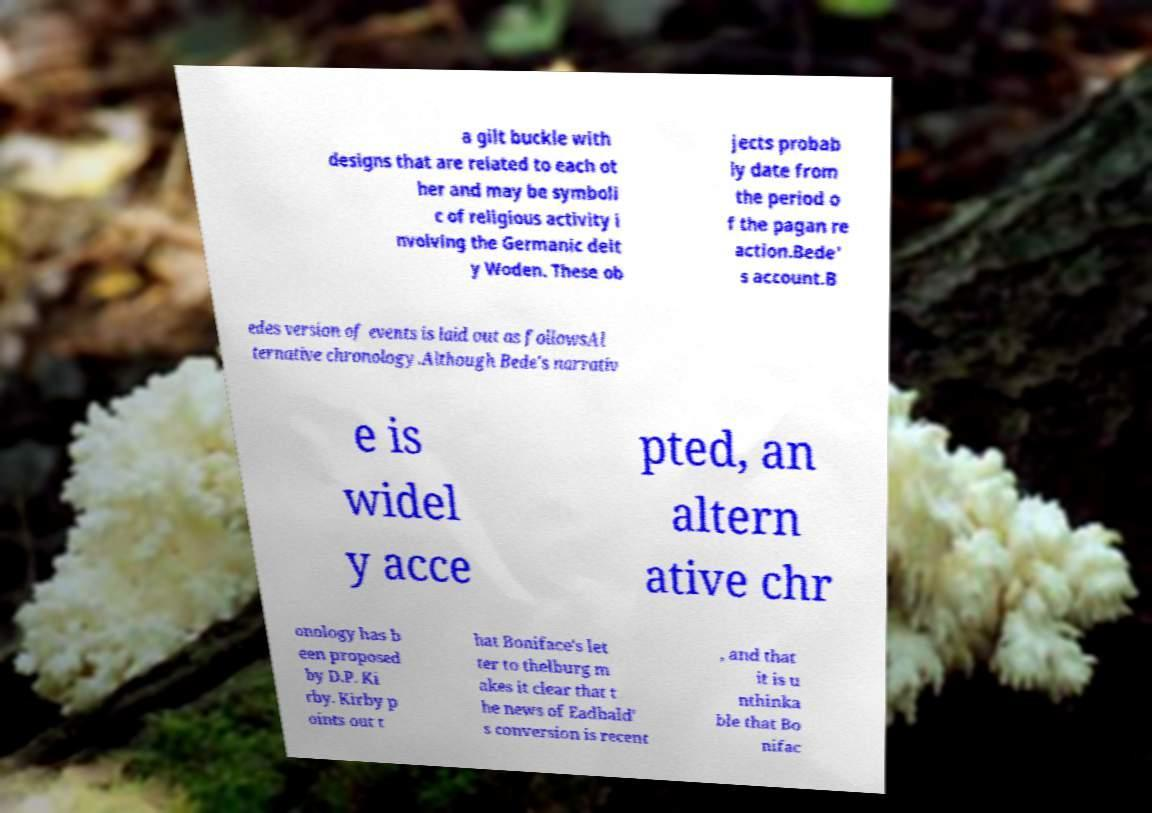For documentation purposes, I need the text within this image transcribed. Could you provide that? a gilt buckle with designs that are related to each ot her and may be symboli c of religious activity i nvolving the Germanic deit y Woden. These ob jects probab ly date from the period o f the pagan re action.Bede' s account.B edes version of events is laid out as followsAl ternative chronology.Although Bede's narrativ e is widel y acce pted, an altern ative chr onology has b een proposed by D.P. Ki rby. Kirby p oints out t hat Boniface's let ter to thelburg m akes it clear that t he news of Eadbald' s conversion is recent , and that it is u nthinka ble that Bo nifac 